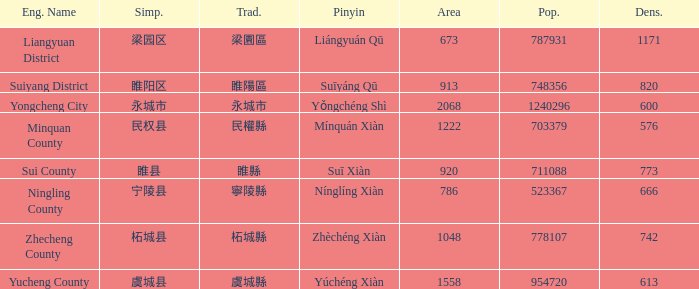What is the traditional form for 宁陵县? 寧陵縣. 